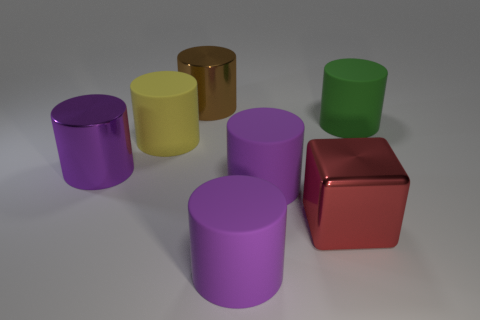Does the red metallic block have the same size as the thing behind the green matte cylinder?
Offer a very short reply. Yes. What is the color of the shiny cylinder that is the same size as the brown object?
Provide a succinct answer. Purple. What size is the purple shiny object?
Your answer should be compact. Large. Do the object to the left of the yellow cylinder and the big yellow cylinder have the same material?
Your answer should be very brief. No. Is the large red object the same shape as the big brown thing?
Provide a short and direct response. No. The shiny object right of the metal cylinder behind the big purple shiny thing that is in front of the large brown cylinder is what shape?
Provide a short and direct response. Cube. Does the metallic object behind the purple metallic cylinder have the same shape as the big metallic object that is on the left side of the yellow rubber thing?
Your answer should be very brief. Yes. Is there a tiny purple block made of the same material as the large green object?
Provide a short and direct response. No. What is the color of the shiny thing to the left of the metallic cylinder on the right side of the large purple metal thing left of the big brown object?
Your answer should be very brief. Purple. Are the purple object that is on the left side of the brown object and the yellow object in front of the big green cylinder made of the same material?
Provide a short and direct response. No. 